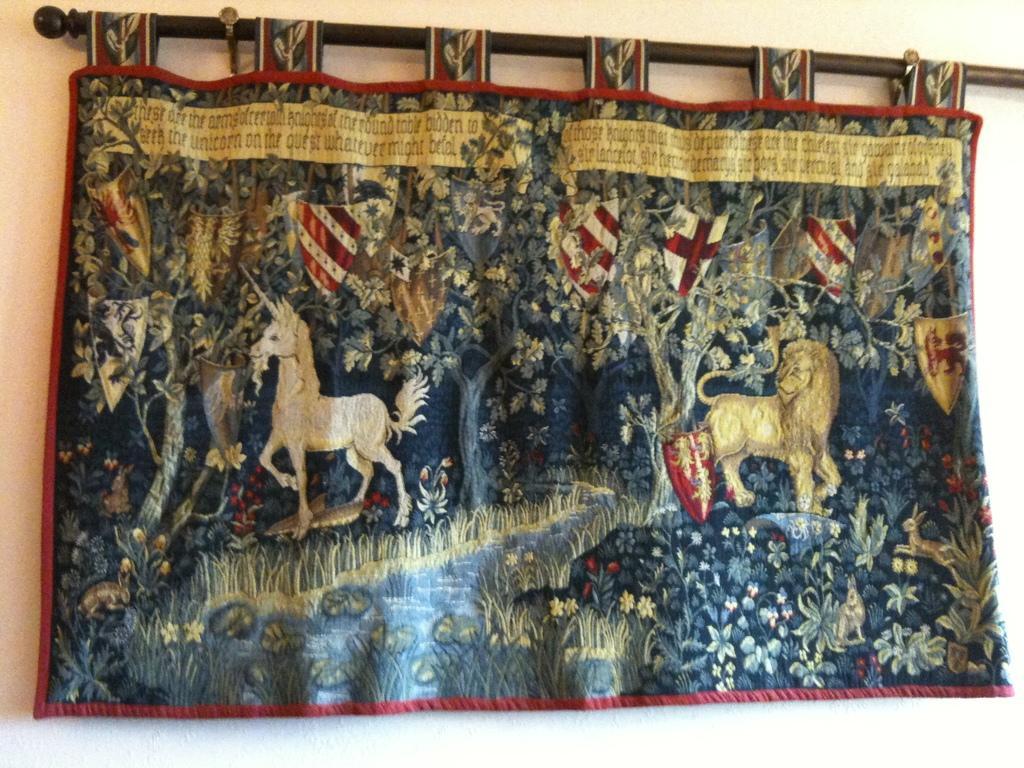How would you summarize this image in a sentence or two? There is a curtain hanged to a rod and on the curtain there is an image of a lion and a horse and few other things,behind the curtain there is a wall. 